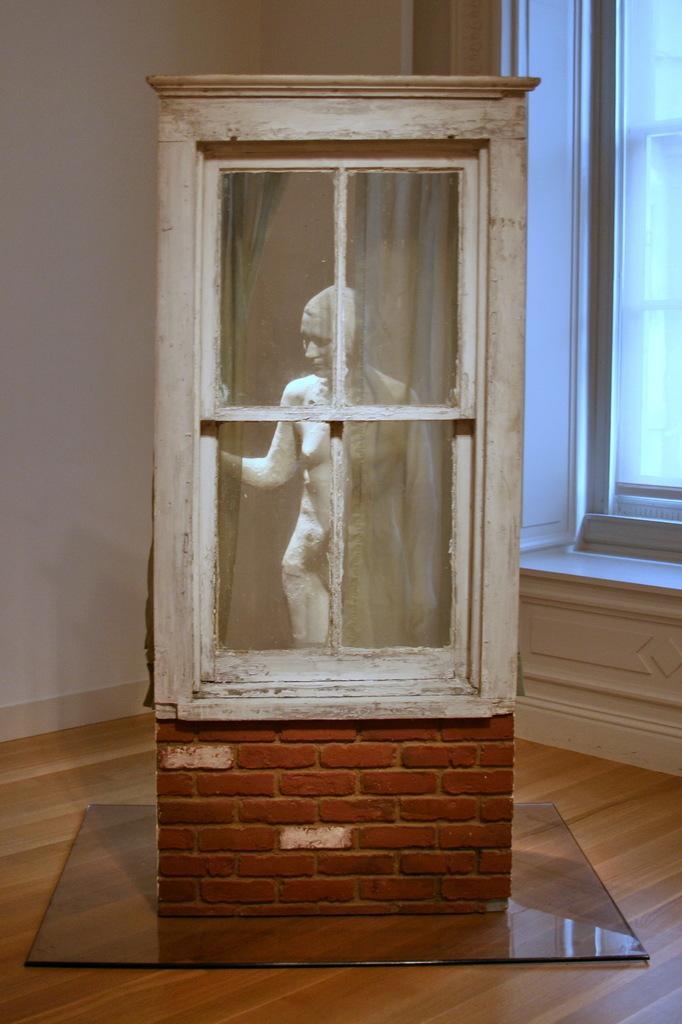How would you summarize this image in a sentence or two? In this image there is a wooden floor, on that there is a box, in that box there is a sculpture, around the box there are walls for that wall there is a window. 